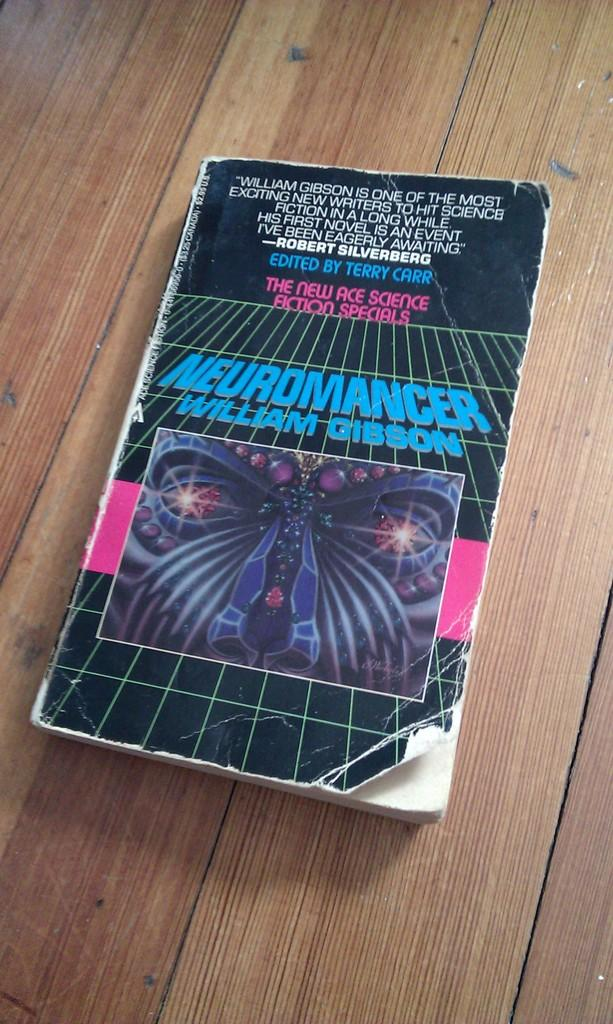What object is present in the image? There is a book in the image. Where is the book located? The book is on a wooden platform. What can be seen on the cover of the book? There is a picture on the book. What can be found on the pages of the book? Text is written on the book. What type of toy is being used to stir the stew in the image? There is no stew or toy present in the image; it features a book on a wooden platform with a picture and text. 